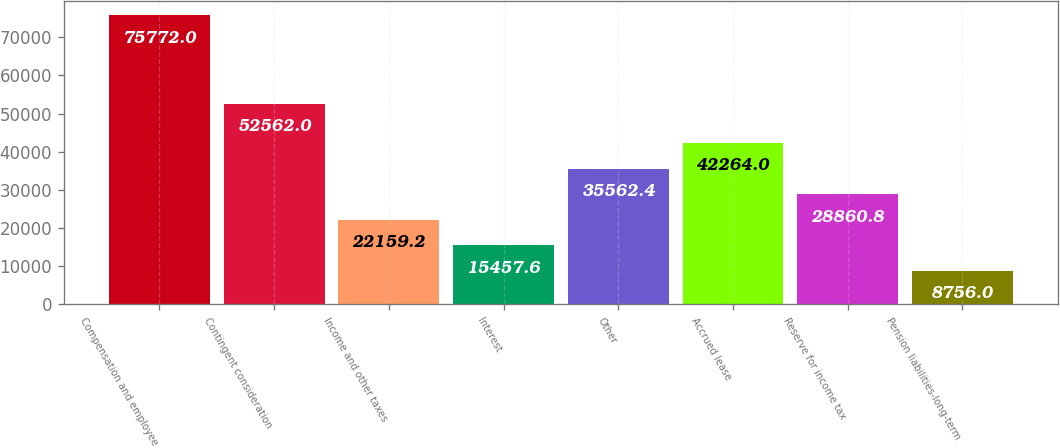<chart> <loc_0><loc_0><loc_500><loc_500><bar_chart><fcel>Compensation and employee<fcel>Contingent consideration<fcel>Income and other taxes<fcel>Interest<fcel>Other<fcel>Accrued lease<fcel>Reserve for income tax<fcel>Pension liabilities-long-term<nl><fcel>75772<fcel>52562<fcel>22159.2<fcel>15457.6<fcel>35562.4<fcel>42264<fcel>28860.8<fcel>8756<nl></chart> 